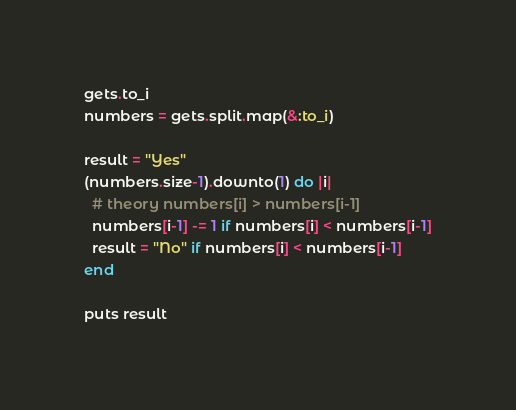Convert code to text. <code><loc_0><loc_0><loc_500><loc_500><_Ruby_>gets.to_i
numbers = gets.split.map(&:to_i)

result = "Yes"
(numbers.size-1).downto(1) do |i|
  # theory numbers[i] > numbers[i-1]
  numbers[i-1] -= 1 if numbers[i] < numbers[i-1]
  result = "No" if numbers[i] < numbers[i-1]
end

puts result</code> 